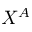Convert formula to latex. <formula><loc_0><loc_0><loc_500><loc_500>X ^ { A }</formula> 